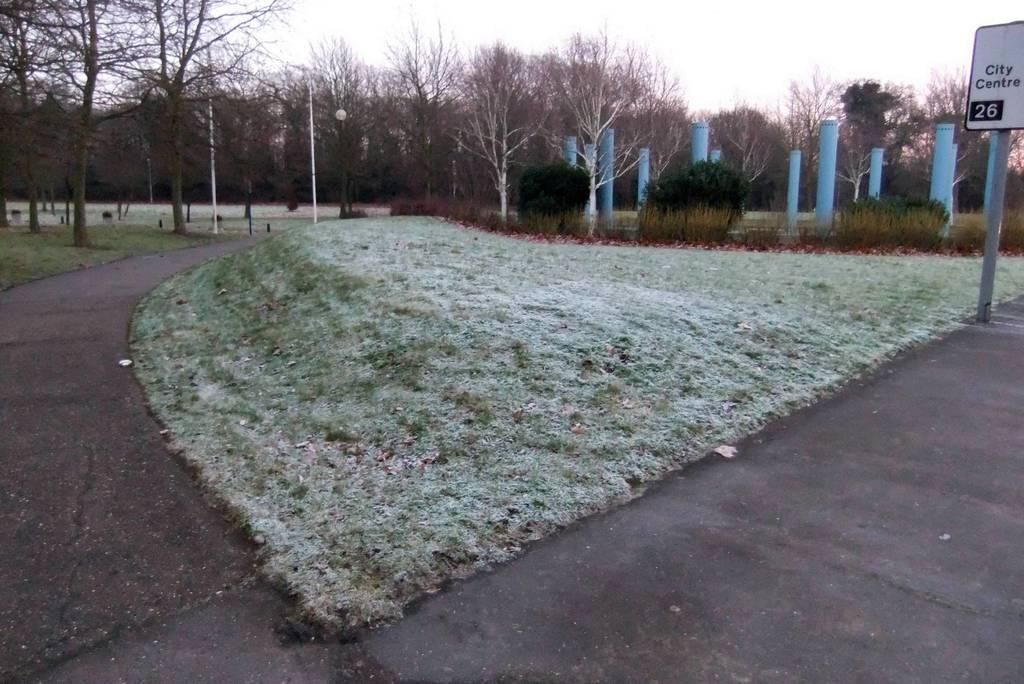What can be seen on the left side of the image? There is a road on the left side of the image. What type of landscape surrounds the road? Grassland is present on either side of the road. What can be seen above the grassland? Trees are visible over the grassland. What is located on the right side of the image? There is a name board on the right side of the image. What is visible above the name board? The sky is visible above the name board. Where is the faucet located in the image? There is no faucet present in the image. Can you hear the sound of a pump in the image? The image is silent, and there is no indication of a pump or any sound. 